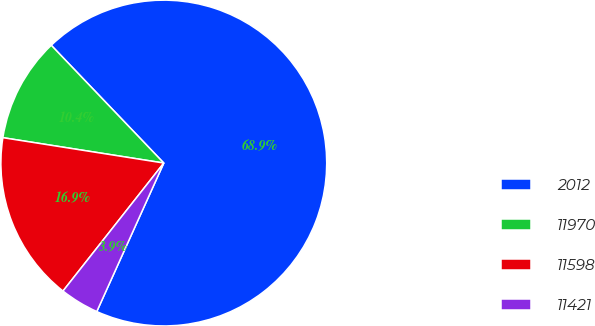Convert chart to OTSL. <chart><loc_0><loc_0><loc_500><loc_500><pie_chart><fcel>2012<fcel>11970<fcel>11598<fcel>11421<nl><fcel>68.88%<fcel>10.37%<fcel>16.87%<fcel>3.87%<nl></chart> 